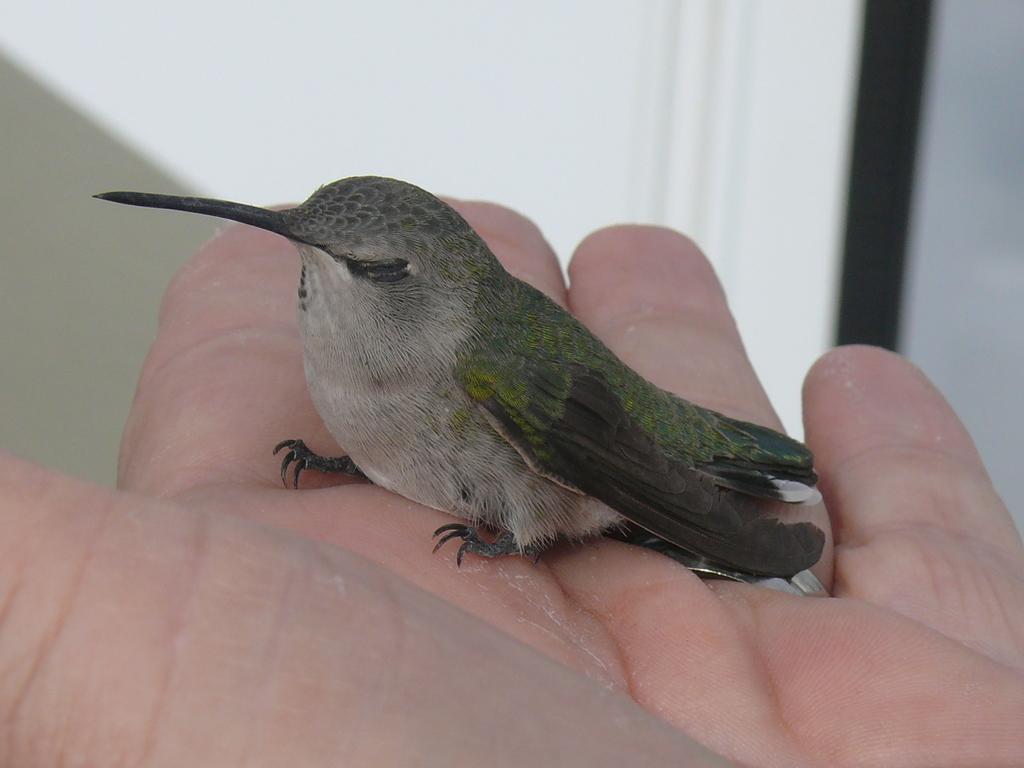How would you summarize this image in a sentence or two? In this age I can see the bird on the person's hand. The bird is in green, black and cream color. Background is in white and black color. 